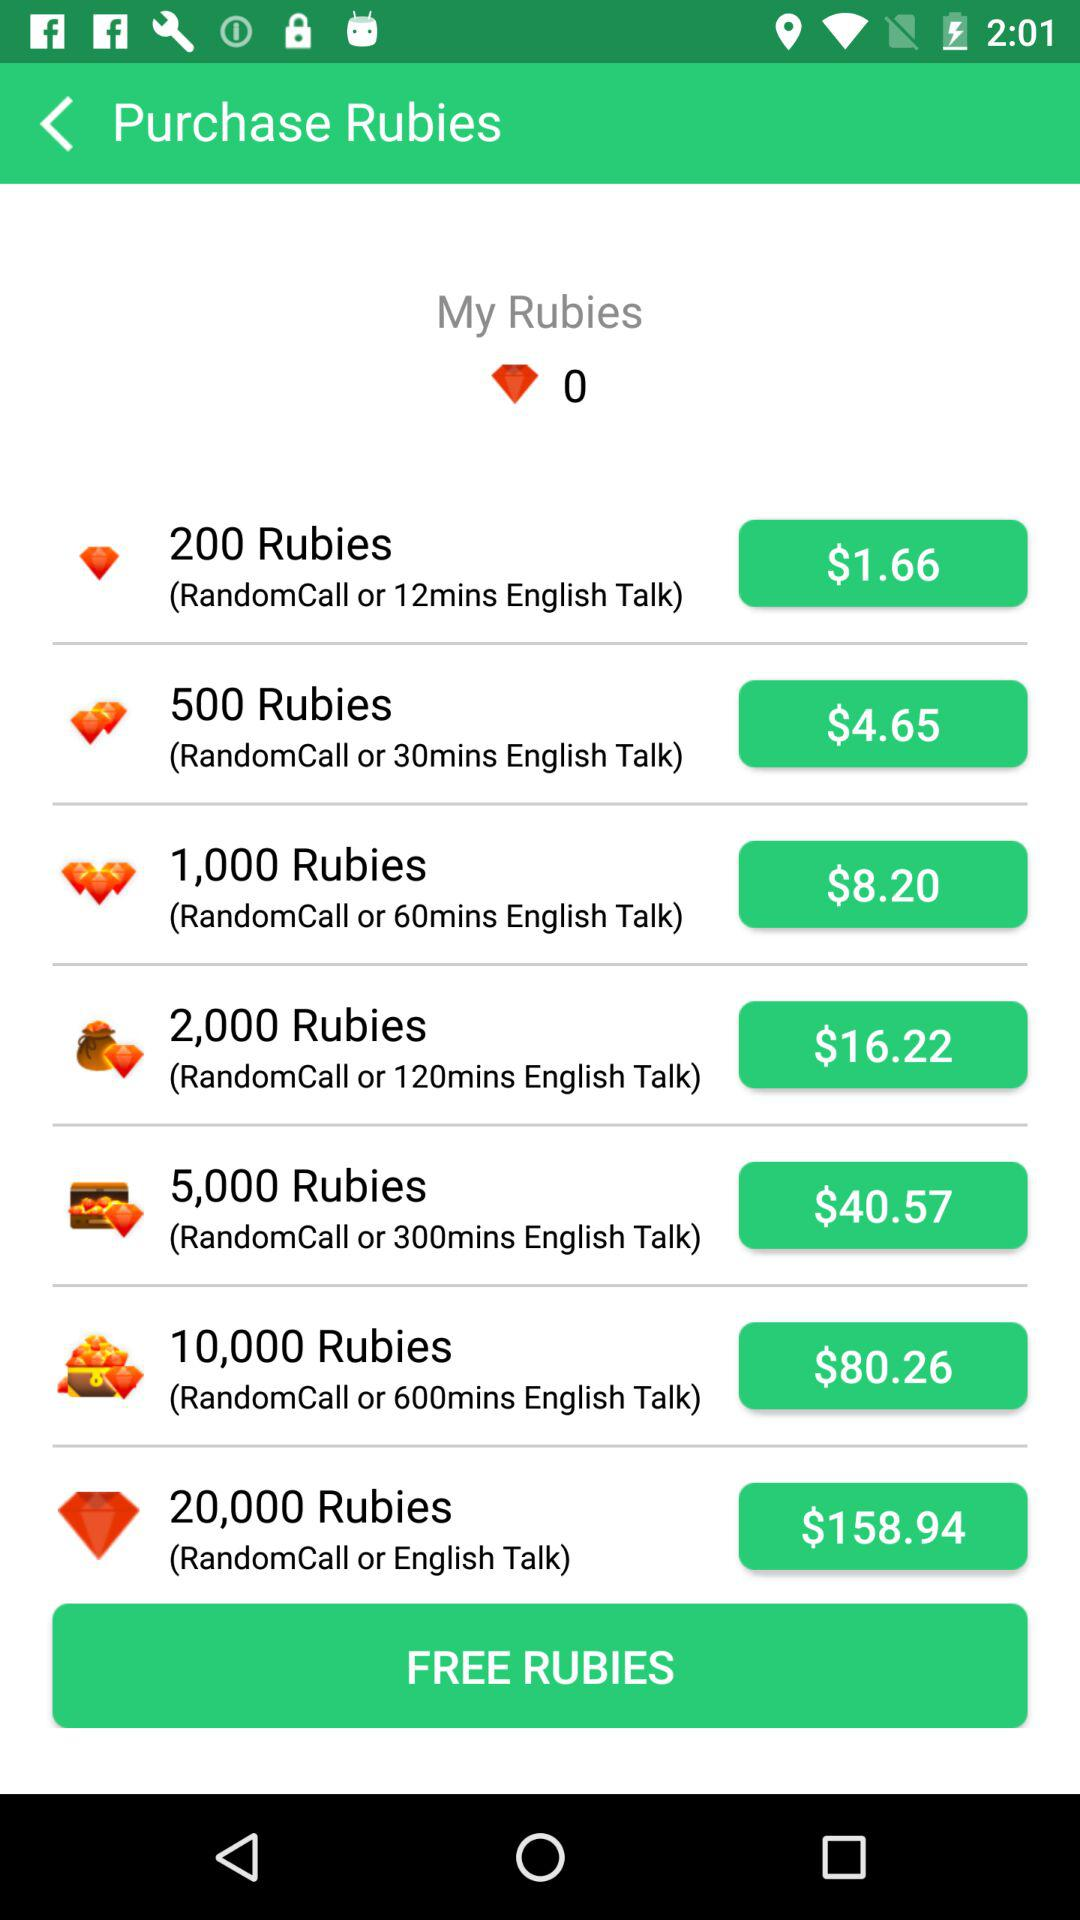What is the total count of rubies?
When the provided information is insufficient, respond with <no answer>. <no answer> 